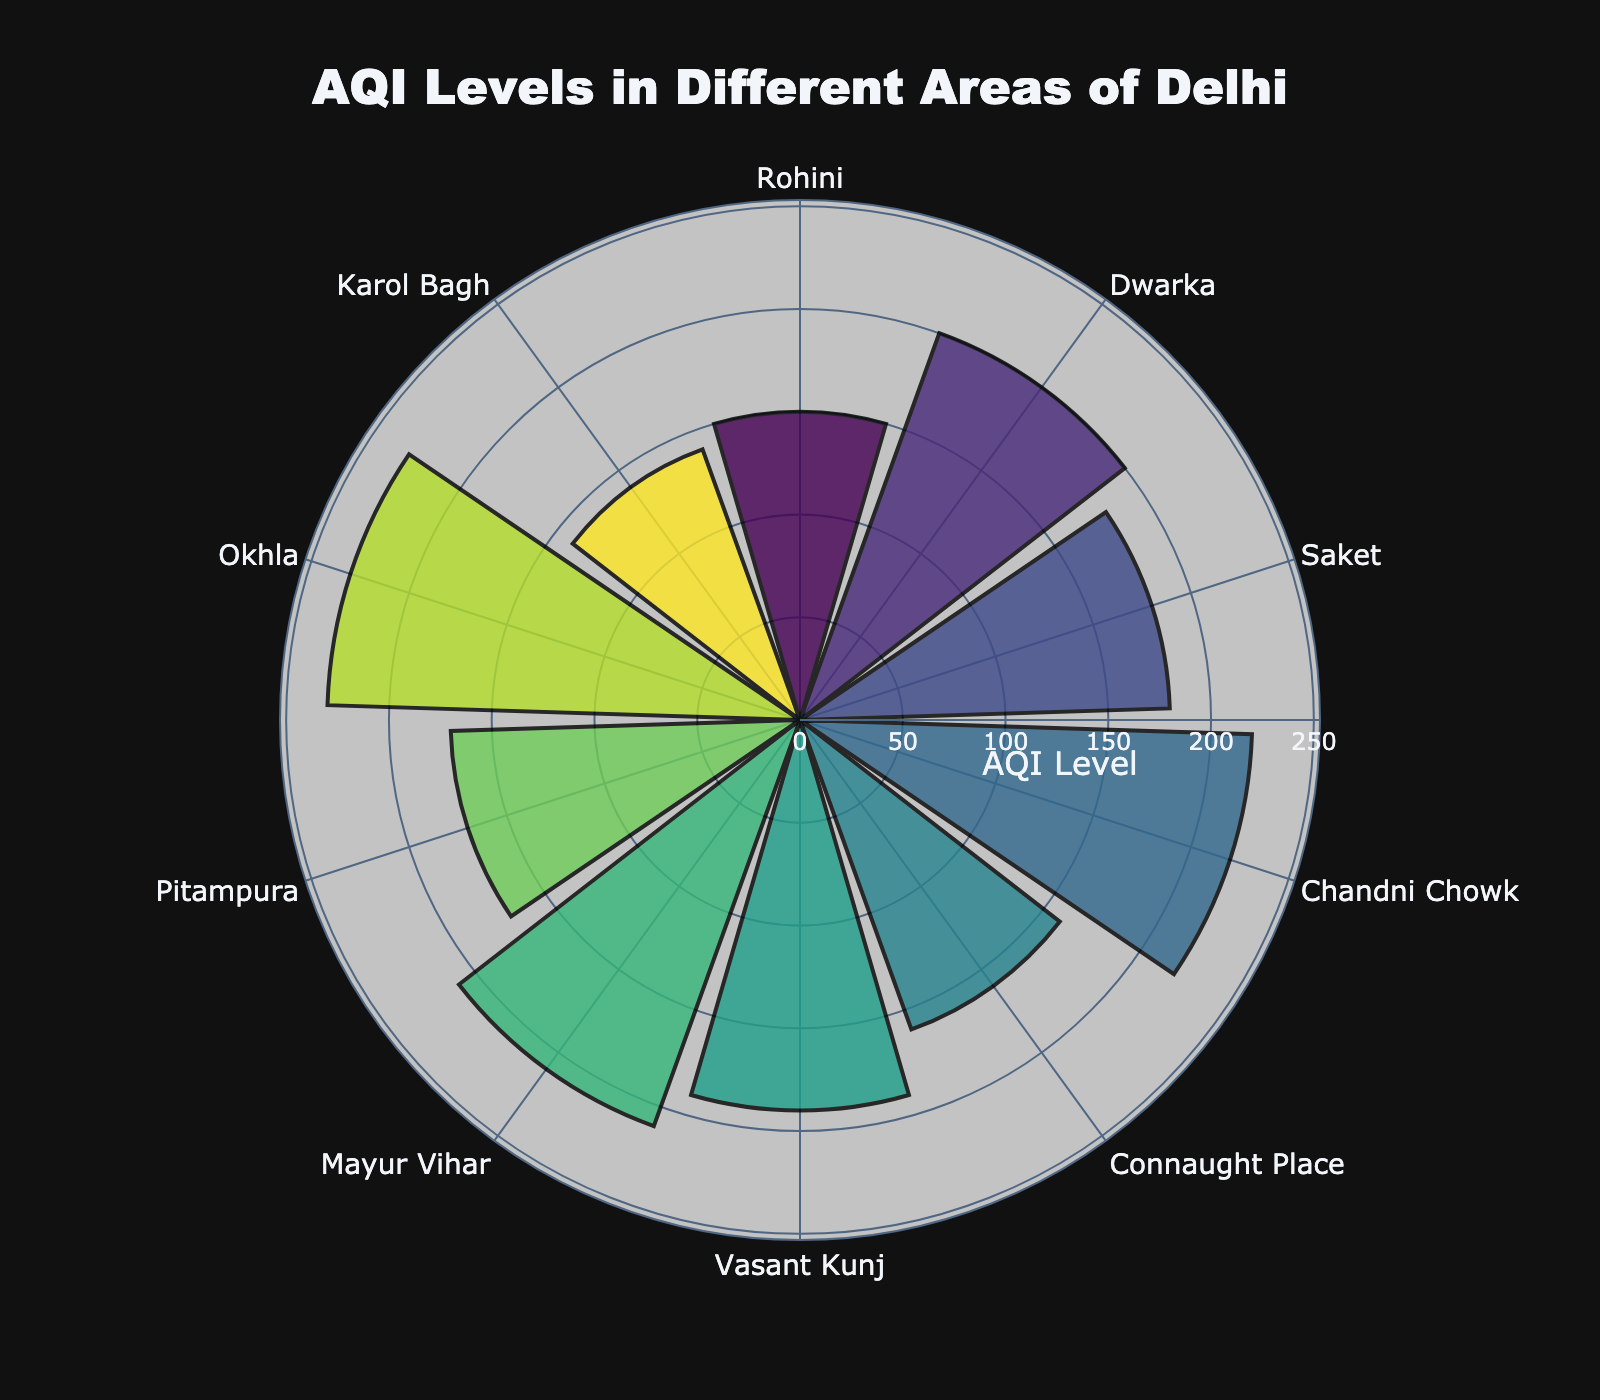What's the highest AQI level among the areas? The areas and their corresponding AQI levels are represented by different bars. By looking at the bar reaching the highest radial value, we see that Okhla has the highest AQI level of 230.
Answer: 230 What's the median AQI level of the listed areas? First, list all AQI levels in ascending order: 140, 150, 160, 170, 180, 190, 200, 210, 220, 230. Since there are 10 values, the median is the average of the 5th and 6th values: (180 + 190) / 2 = 185.
Answer: 185 Which area has the lowest AQI level? By identifying the bar that reaches the lowest radial value, we see that Karol Bagh has the lowest AQI level of 140.
Answer: Karol Bagh How many areas have an AQI level above 200? Count the number of bars extending beyond the 200 mark in the radial axis: Dwarka, Mayur Vihar, Chandni Chowk, and Okhla. There are 4 areas.
Answer: 4 What's the average AQI level across all areas? Sum all AQI levels and divide by the number of areas: (150 + 200 + 180 + 220 + 160 + 190 + 210 + 170 + 230 + 140) / 10 = 1850 / 10 = 185.
Answer: 185 Which two areas have the closest AQI levels, and what's the difference? By comparing each pair's AQI levels, Vasant Kunj and Saket have the closest values (190 and 180). The difference is 190 - 180 = 10.
Answer: Vasant Kunj, Saket, 10 How much higher is the AQI level in Okhla compared to Karol Bagh? Subtract the AQI level of Karol Bagh from that of Okhla: 230 - 140 = 90.
Answer: 90 Which area falls exactly in the middle in terms of AQI levels? Ordering the areas by AQI levels: Karol Bagh, Rohini, Connaught Place, Pitampura, Saket, Vasant Kunj, Dwarka, Mayur Vihar, Chandni Chowk, and Okhla, we find Vasant Kunj in the median position with an AQI of 190.
Answer: Vasant Kunj Is there any area with an AQI level within the range of 150-160? By checking the AQI levels, we see that Rohini (150) and Connaught Place (160) fall within this range.
Answer: Yes Which area has an AQI level closest to 200 but not over it? Rohini has an AQI of 150, Connaught Place has 160, Pitampura has 170, Saket has 180, and Vasant Kunj has 190—all less than 200. Vasant Kunj, with an AQI of 190, is the closest.
Answer: Vasant Kunj 